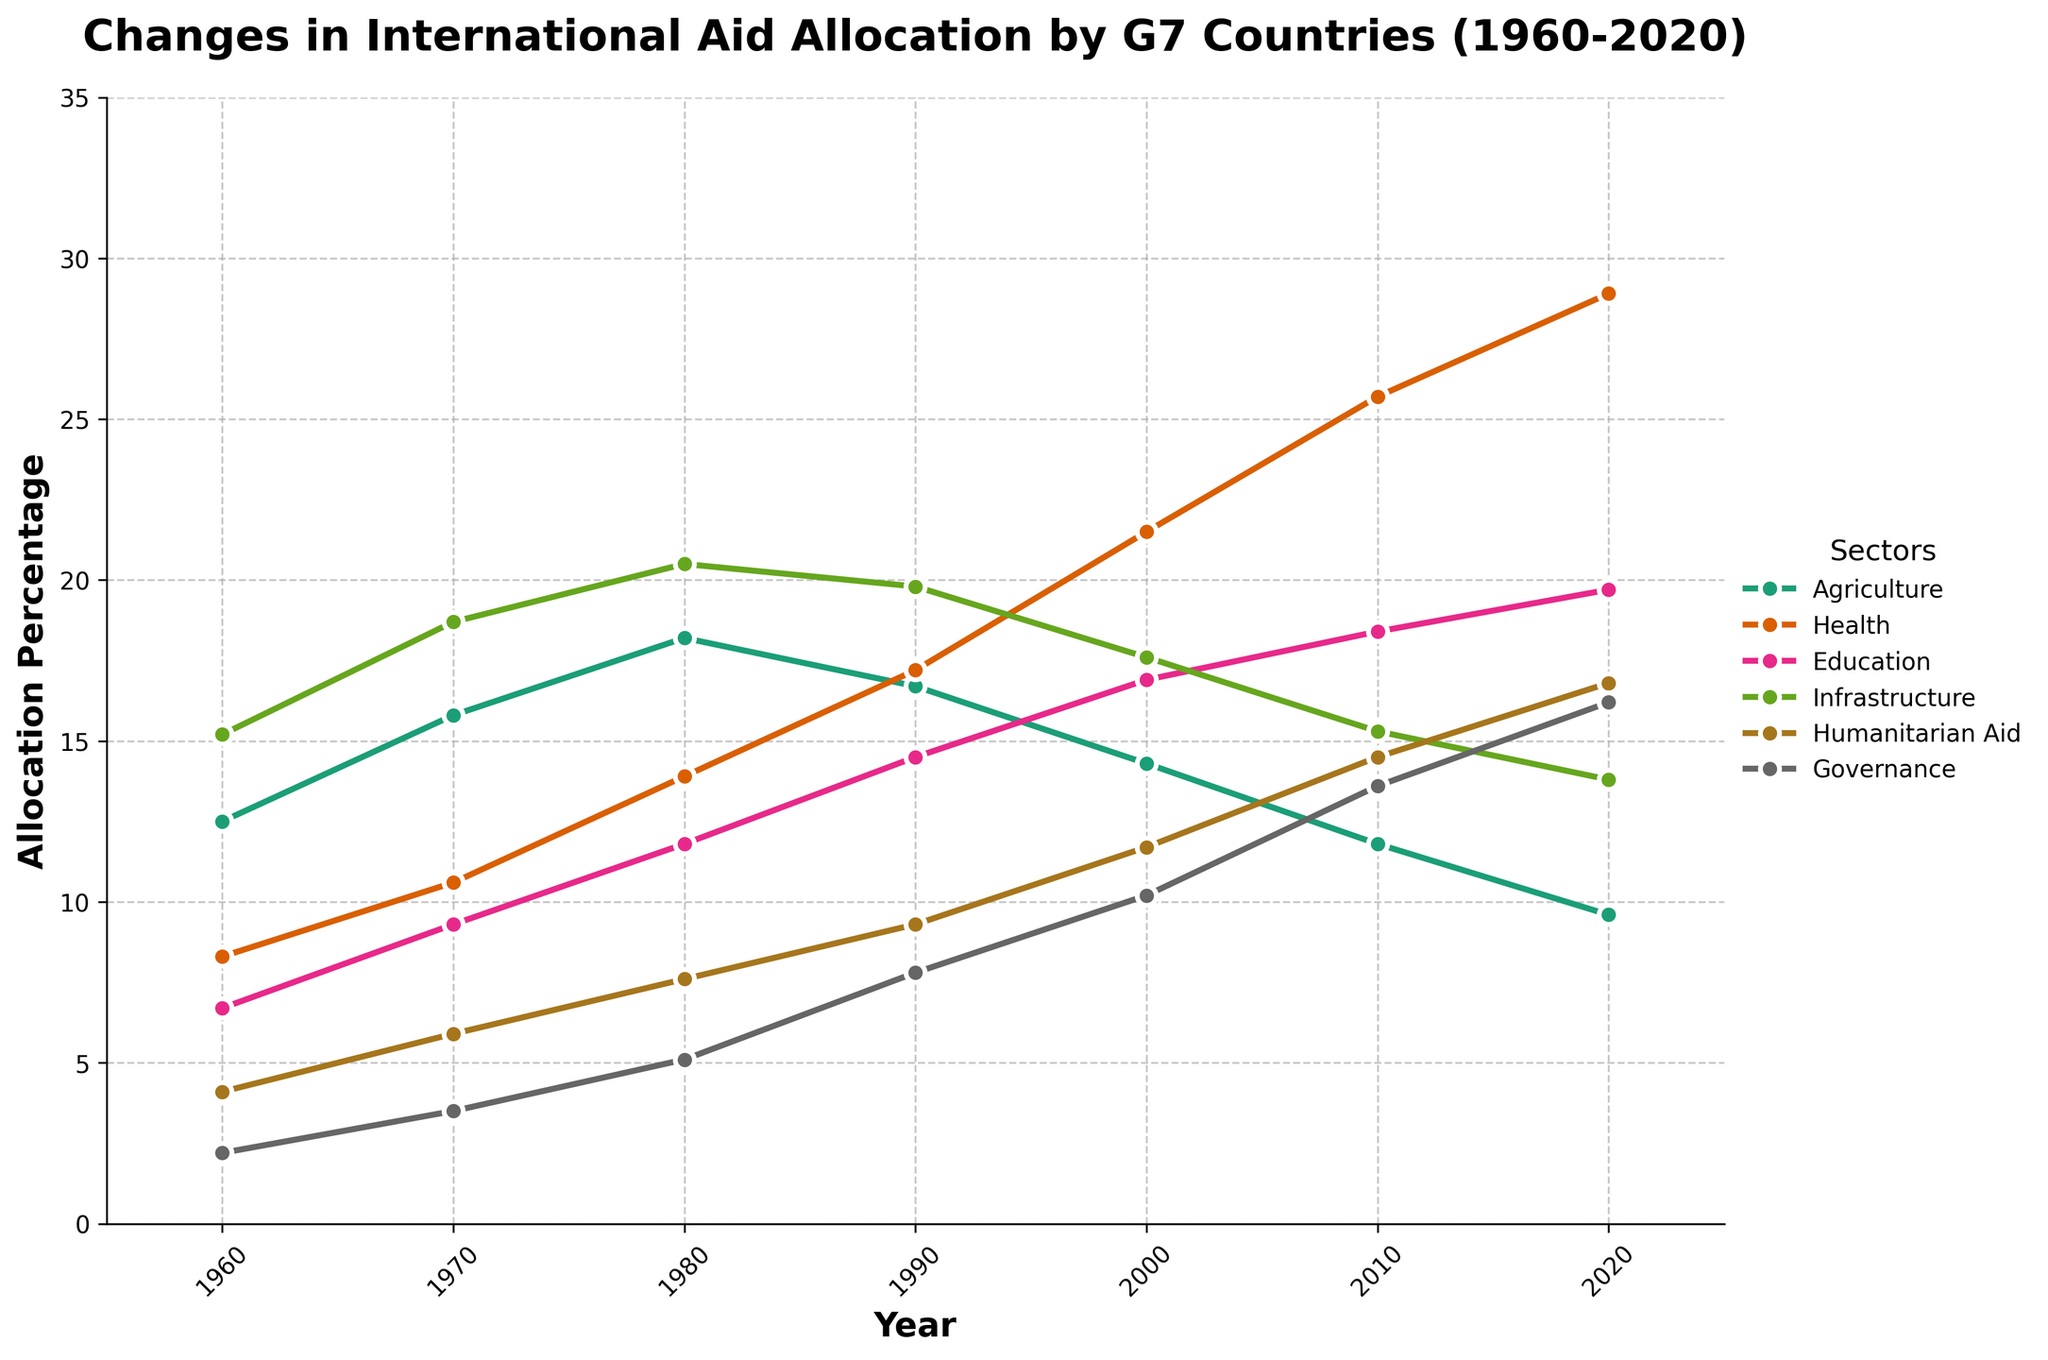What sector had the biggest increase in international aid allocation from 1960 to 2020? First, identify the allocation percentage for each sector in 1960 and in 2020. Calculate the difference for each sector. The differences are: Agriculture (-2.9%), Health (20.6%), Education (13.0%), Infrastructure (-1.4%), Humanitarian Aid (12.7%), Governance (14.0%). Health has the biggest increase with 20.6%.
Answer: Health Which sector had the lowest allocation percentage in the year 2000? Look at the allocation percentages for all sectors in the year 2000. The values are: Agriculture (14.3%), Health (21.5%), Education (16.9%), Infrastructure (17.6%), Humanitarian Aid (11.7%), Governance (10.2%). Governance has the lowest percentage at 10.2%.
Answer: Governance What is the average allocation percentage for agriculture over the years provided? Sum the allocation percentages for agriculture across all years and then divide by the total number of years. The values are: 12.5 + 15.8 + 18.2 + 16.7 + 14.3 + 11.8 + 9.6 = 98.9. There are 7 years, so the average is 98.9 / 7 ≈ 14.1%.
Answer: 14.1% By how much did the allocation for humanitarian aid increase from 1960 to 2010? Subtract the 1960 value from the 2010 value for humanitarian aid. The values are 14.5 (2010) and 4.1 (1960), so 14.5 - 4.1 = 10.4.
Answer: 10.4 Which sectors had a consistent increase in their allocation percentages from 1960 to 2020? Compare the allocation percentages for each sector across the years and identify those with constant increases. Health, Education, and Governance show consistent increases in their allocation percentages across this span.
Answer: Health, Education, Governance What year (if any) shows the highest allocation for infrastructure? Check the allocation percentages for infrastructure across all years and identify the highest value. The highest allocation for infrastructure is 20.5% in 1980.
Answer: 1980 How does the allocation of aid between health and agriculture in 2020 compare? Look at the allocation percentages for health and agriculture in 2020. Health is at 28.9% and agriculture is at 9.6%. Health has a much higher allocation than agriculture.
Answer: Health > Agriculture Which sector experienced a decline in allocation between 1980 and 1990? Compare the allocation percentages for each sector between 1980 and 1990. The sectors Agriculture (18.2 to 16.7) and Infrastructure (20.5 to 19.8) experienced declines.
Answer: Agriculture, Infrastructure What sector had the most significant allocation drop from 2000 to 2010? Compare the sector allocation percentages from 2000 to 2010 and find the sector with the largest decrease. Infrastructure decreased from 17.6% (2000) to 15.3% (2010), a drop of 2.3%.
Answer: Infrastructure 